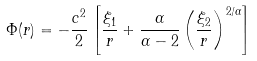<formula> <loc_0><loc_0><loc_500><loc_500>\Phi ( r ) = - \frac { c ^ { 2 } } { 2 } \left [ \frac { \xi _ { 1 } } { r } + \frac { \alpha } { \alpha - 2 } \left ( \frac { \xi _ { 2 } } { r } \right ) ^ { 2 / \alpha } \right ]</formula> 